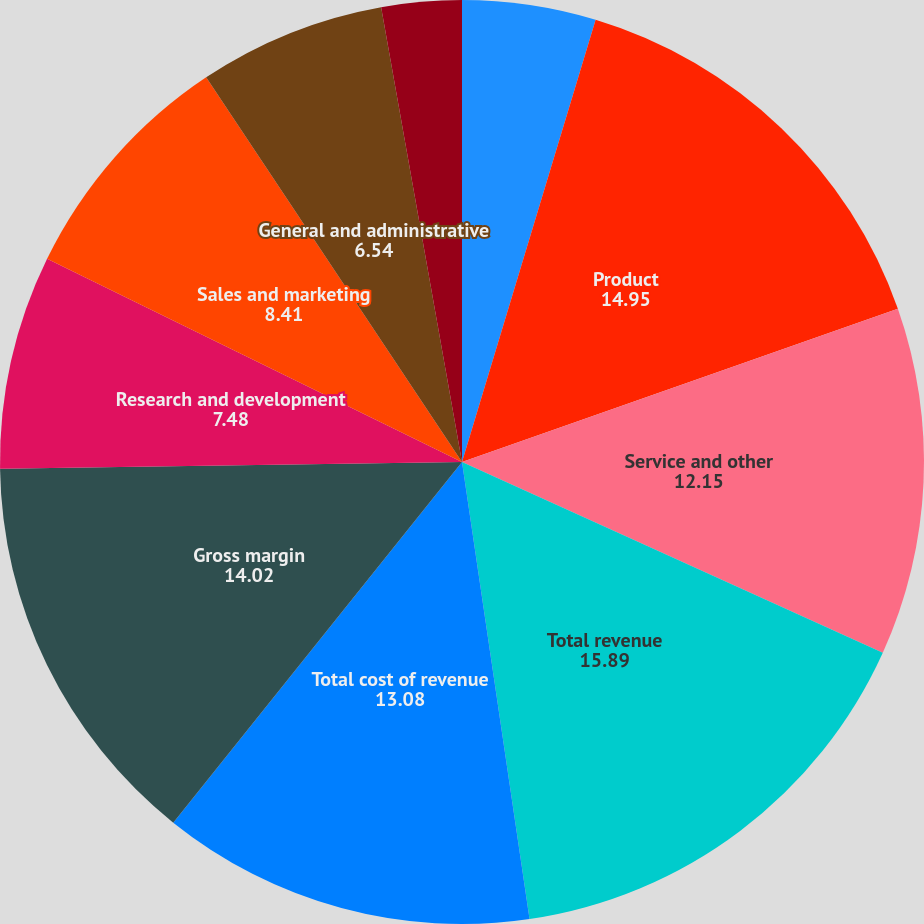Convert chart. <chart><loc_0><loc_0><loc_500><loc_500><pie_chart><fcel>Year Ended June 30<fcel>Product<fcel>Service and other<fcel>Total revenue<fcel>Total cost of revenue<fcel>Gross margin<fcel>Research and development<fcel>Sales and marketing<fcel>General and administrative<fcel>Impairment and restructuring<nl><fcel>4.67%<fcel>14.95%<fcel>12.15%<fcel>15.89%<fcel>13.08%<fcel>14.02%<fcel>7.48%<fcel>8.41%<fcel>6.54%<fcel>2.8%<nl></chart> 